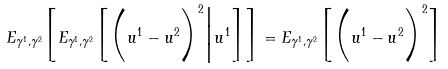<formula> <loc_0><loc_0><loc_500><loc_500>E _ { \gamma ^ { 1 } , \gamma ^ { 2 } } \Big [ E _ { \gamma ^ { 1 } , \gamma ^ { 2 } } \Big [ \Big ( u ^ { 1 } - u ^ { 2 } \Big ) ^ { 2 } \Big | u ^ { 1 } \Big ] \Big ] = E _ { \gamma ^ { 1 } , \gamma ^ { 2 } } \Big [ \Big ( u ^ { 1 } - u ^ { 2 } \Big ) ^ { 2 } \Big ]</formula> 